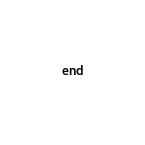Convert code to text. <code><loc_0><loc_0><loc_500><loc_500><_Ruby_>end
</code> 